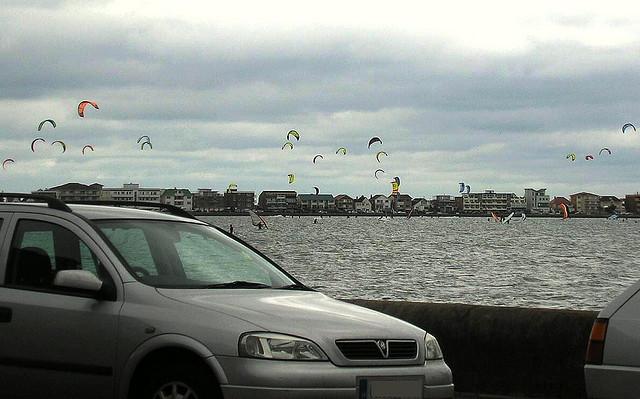Where are the kites flying over?
Quick response, please. Water. What is the color of the car?
Quick response, please. Silver. What color is the car?
Concise answer only. Gray. What is in the sky?
Short answer required. Kites. Is a train shown in this picture?
Short answer required. No. Is there a dog inside the car?
Write a very short answer. No. 